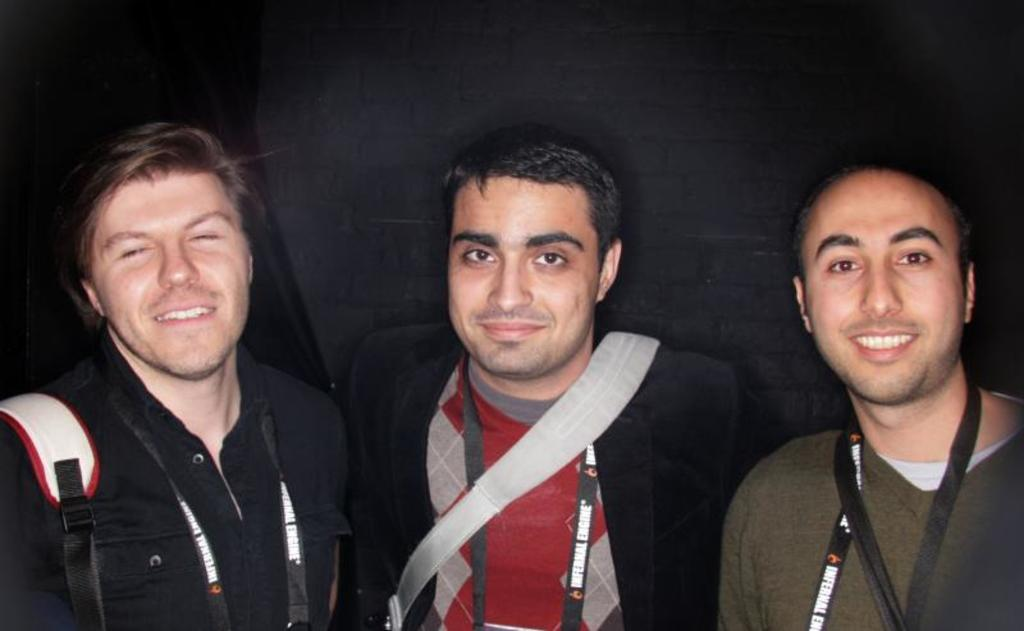How many people are in the image? There are three people in the foreground of the image. What can be seen in the background of the image? The background of the image is black. Can you describe the person in the image who is carrying a backpack? Yes, there is a person wearing a backpack in the image. What language is being spoken by the things in the image? There are no "things" present in the image, and therefore no language can be attributed to them. 